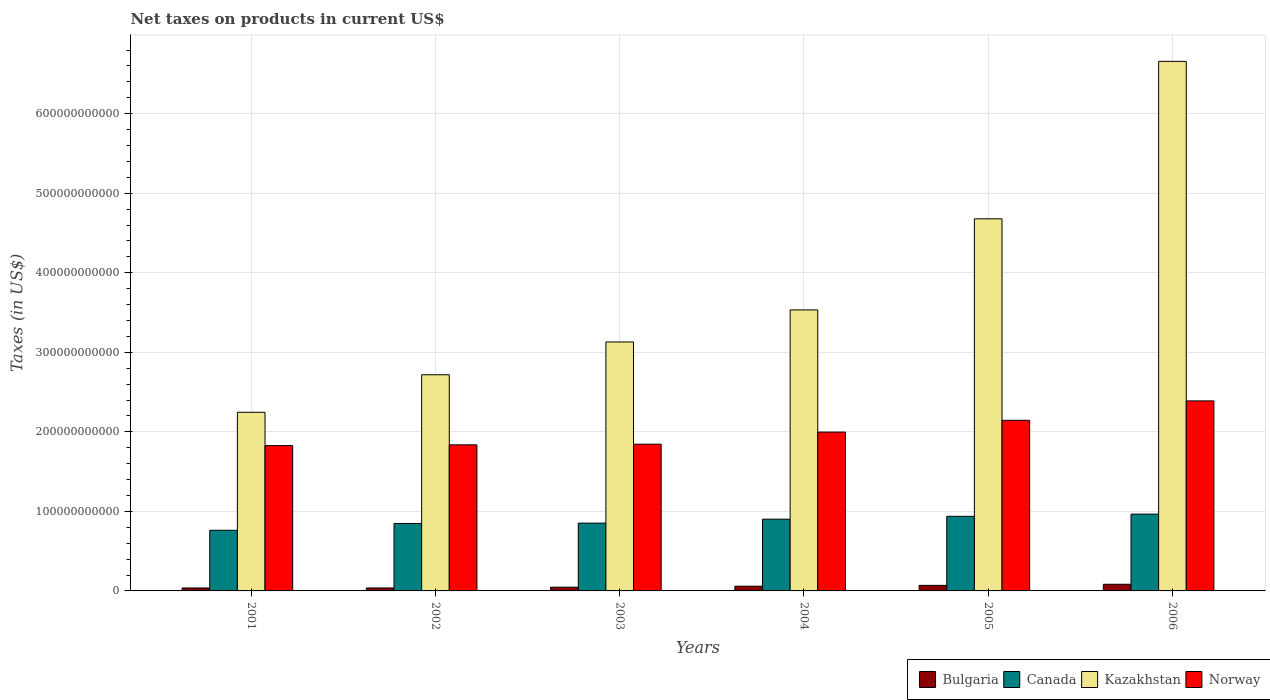How many different coloured bars are there?
Your answer should be compact. 4. How many groups of bars are there?
Give a very brief answer. 6. Are the number of bars per tick equal to the number of legend labels?
Your response must be concise. Yes. Are the number of bars on each tick of the X-axis equal?
Keep it short and to the point. Yes. How many bars are there on the 4th tick from the left?
Give a very brief answer. 4. How many bars are there on the 3rd tick from the right?
Offer a terse response. 4. What is the net taxes on products in Bulgaria in 2006?
Offer a terse response. 8.36e+09. Across all years, what is the maximum net taxes on products in Canada?
Provide a succinct answer. 9.66e+1. Across all years, what is the minimum net taxes on products in Kazakhstan?
Your answer should be compact. 2.25e+11. What is the total net taxes on products in Canada in the graph?
Offer a very short reply. 5.27e+11. What is the difference between the net taxes on products in Norway in 2001 and that in 2006?
Offer a very short reply. -5.62e+1. What is the difference between the net taxes on products in Kazakhstan in 2006 and the net taxes on products in Canada in 2004?
Your answer should be compact. 5.76e+11. What is the average net taxes on products in Canada per year?
Provide a succinct answer. 8.78e+1. In the year 2004, what is the difference between the net taxes on products in Norway and net taxes on products in Kazakhstan?
Make the answer very short. -1.54e+11. In how many years, is the net taxes on products in Kazakhstan greater than 180000000000 US$?
Provide a succinct answer. 6. What is the ratio of the net taxes on products in Norway in 2005 to that in 2006?
Keep it short and to the point. 0.9. Is the net taxes on products in Kazakhstan in 2001 less than that in 2002?
Your answer should be compact. Yes. What is the difference between the highest and the second highest net taxes on products in Norway?
Offer a terse response. 2.44e+1. What is the difference between the highest and the lowest net taxes on products in Canada?
Your response must be concise. 2.03e+1. Is the sum of the net taxes on products in Norway in 2001 and 2004 greater than the maximum net taxes on products in Bulgaria across all years?
Your answer should be very brief. Yes. What does the 4th bar from the left in 2006 represents?
Offer a very short reply. Norway. Is it the case that in every year, the sum of the net taxes on products in Norway and net taxes on products in Kazakhstan is greater than the net taxes on products in Canada?
Your answer should be very brief. Yes. What is the difference between two consecutive major ticks on the Y-axis?
Ensure brevity in your answer.  1.00e+11. Does the graph contain any zero values?
Ensure brevity in your answer.  No. Does the graph contain grids?
Keep it short and to the point. Yes. What is the title of the graph?
Keep it short and to the point. Net taxes on products in current US$. Does "Libya" appear as one of the legend labels in the graph?
Your answer should be compact. No. What is the label or title of the X-axis?
Give a very brief answer. Years. What is the label or title of the Y-axis?
Your answer should be compact. Taxes (in US$). What is the Taxes (in US$) of Bulgaria in 2001?
Offer a terse response. 3.70e+09. What is the Taxes (in US$) in Canada in 2001?
Offer a very short reply. 7.62e+1. What is the Taxes (in US$) in Kazakhstan in 2001?
Your answer should be very brief. 2.25e+11. What is the Taxes (in US$) in Norway in 2001?
Provide a succinct answer. 1.83e+11. What is the Taxes (in US$) of Bulgaria in 2002?
Make the answer very short. 3.73e+09. What is the Taxes (in US$) of Canada in 2002?
Offer a very short reply. 8.48e+1. What is the Taxes (in US$) in Kazakhstan in 2002?
Provide a short and direct response. 2.72e+11. What is the Taxes (in US$) in Norway in 2002?
Provide a succinct answer. 1.84e+11. What is the Taxes (in US$) in Bulgaria in 2003?
Offer a very short reply. 4.69e+09. What is the Taxes (in US$) of Canada in 2003?
Offer a terse response. 8.53e+1. What is the Taxes (in US$) in Kazakhstan in 2003?
Keep it short and to the point. 3.13e+11. What is the Taxes (in US$) in Norway in 2003?
Provide a short and direct response. 1.85e+11. What is the Taxes (in US$) in Bulgaria in 2004?
Your response must be concise. 5.94e+09. What is the Taxes (in US$) of Canada in 2004?
Offer a terse response. 9.02e+1. What is the Taxes (in US$) of Kazakhstan in 2004?
Keep it short and to the point. 3.53e+11. What is the Taxes (in US$) of Norway in 2004?
Give a very brief answer. 2.00e+11. What is the Taxes (in US$) of Bulgaria in 2005?
Provide a short and direct response. 6.99e+09. What is the Taxes (in US$) of Canada in 2005?
Ensure brevity in your answer.  9.38e+1. What is the Taxes (in US$) in Kazakhstan in 2005?
Ensure brevity in your answer.  4.68e+11. What is the Taxes (in US$) in Norway in 2005?
Provide a succinct answer. 2.15e+11. What is the Taxes (in US$) of Bulgaria in 2006?
Your answer should be compact. 8.36e+09. What is the Taxes (in US$) of Canada in 2006?
Your answer should be compact. 9.66e+1. What is the Taxes (in US$) in Kazakhstan in 2006?
Offer a very short reply. 6.66e+11. What is the Taxes (in US$) of Norway in 2006?
Your answer should be very brief. 2.39e+11. Across all years, what is the maximum Taxes (in US$) of Bulgaria?
Make the answer very short. 8.36e+09. Across all years, what is the maximum Taxes (in US$) in Canada?
Offer a very short reply. 9.66e+1. Across all years, what is the maximum Taxes (in US$) in Kazakhstan?
Your response must be concise. 6.66e+11. Across all years, what is the maximum Taxes (in US$) in Norway?
Your answer should be compact. 2.39e+11. Across all years, what is the minimum Taxes (in US$) in Bulgaria?
Offer a very short reply. 3.70e+09. Across all years, what is the minimum Taxes (in US$) of Canada?
Provide a short and direct response. 7.62e+1. Across all years, what is the minimum Taxes (in US$) of Kazakhstan?
Offer a terse response. 2.25e+11. Across all years, what is the minimum Taxes (in US$) of Norway?
Offer a very short reply. 1.83e+11. What is the total Taxes (in US$) in Bulgaria in the graph?
Ensure brevity in your answer.  3.34e+1. What is the total Taxes (in US$) of Canada in the graph?
Your response must be concise. 5.27e+11. What is the total Taxes (in US$) of Kazakhstan in the graph?
Provide a short and direct response. 2.30e+12. What is the total Taxes (in US$) in Norway in the graph?
Provide a short and direct response. 1.20e+12. What is the difference between the Taxes (in US$) in Bulgaria in 2001 and that in 2002?
Make the answer very short. -3.24e+07. What is the difference between the Taxes (in US$) of Canada in 2001 and that in 2002?
Provide a short and direct response. -8.55e+09. What is the difference between the Taxes (in US$) in Kazakhstan in 2001 and that in 2002?
Your answer should be compact. -4.72e+1. What is the difference between the Taxes (in US$) of Norway in 2001 and that in 2002?
Your answer should be compact. -9.57e+08. What is the difference between the Taxes (in US$) in Bulgaria in 2001 and that in 2003?
Offer a very short reply. -9.96e+08. What is the difference between the Taxes (in US$) in Canada in 2001 and that in 2003?
Your answer should be compact. -9.03e+09. What is the difference between the Taxes (in US$) in Kazakhstan in 2001 and that in 2003?
Your answer should be very brief. -8.84e+1. What is the difference between the Taxes (in US$) of Norway in 2001 and that in 2003?
Provide a succinct answer. -1.81e+09. What is the difference between the Taxes (in US$) of Bulgaria in 2001 and that in 2004?
Offer a terse response. -2.25e+09. What is the difference between the Taxes (in US$) of Canada in 2001 and that in 2004?
Give a very brief answer. -1.40e+1. What is the difference between the Taxes (in US$) of Kazakhstan in 2001 and that in 2004?
Provide a succinct answer. -1.29e+11. What is the difference between the Taxes (in US$) in Norway in 2001 and that in 2004?
Provide a succinct answer. -1.70e+1. What is the difference between the Taxes (in US$) of Bulgaria in 2001 and that in 2005?
Ensure brevity in your answer.  -3.29e+09. What is the difference between the Taxes (in US$) of Canada in 2001 and that in 2005?
Provide a succinct answer. -1.75e+1. What is the difference between the Taxes (in US$) in Kazakhstan in 2001 and that in 2005?
Your answer should be very brief. -2.43e+11. What is the difference between the Taxes (in US$) of Norway in 2001 and that in 2005?
Your answer should be compact. -3.18e+1. What is the difference between the Taxes (in US$) in Bulgaria in 2001 and that in 2006?
Provide a succinct answer. -4.66e+09. What is the difference between the Taxes (in US$) in Canada in 2001 and that in 2006?
Make the answer very short. -2.03e+1. What is the difference between the Taxes (in US$) of Kazakhstan in 2001 and that in 2006?
Your answer should be very brief. -4.41e+11. What is the difference between the Taxes (in US$) in Norway in 2001 and that in 2006?
Keep it short and to the point. -5.62e+1. What is the difference between the Taxes (in US$) in Bulgaria in 2002 and that in 2003?
Your response must be concise. -9.63e+08. What is the difference between the Taxes (in US$) of Canada in 2002 and that in 2003?
Your response must be concise. -4.84e+08. What is the difference between the Taxes (in US$) of Kazakhstan in 2002 and that in 2003?
Give a very brief answer. -4.12e+1. What is the difference between the Taxes (in US$) of Norway in 2002 and that in 2003?
Provide a short and direct response. -8.49e+08. What is the difference between the Taxes (in US$) in Bulgaria in 2002 and that in 2004?
Provide a short and direct response. -2.21e+09. What is the difference between the Taxes (in US$) in Canada in 2002 and that in 2004?
Give a very brief answer. -5.42e+09. What is the difference between the Taxes (in US$) of Kazakhstan in 2002 and that in 2004?
Offer a terse response. -8.15e+1. What is the difference between the Taxes (in US$) of Norway in 2002 and that in 2004?
Your response must be concise. -1.60e+1. What is the difference between the Taxes (in US$) in Bulgaria in 2002 and that in 2005?
Offer a terse response. -3.26e+09. What is the difference between the Taxes (in US$) of Canada in 2002 and that in 2005?
Give a very brief answer. -8.98e+09. What is the difference between the Taxes (in US$) in Kazakhstan in 2002 and that in 2005?
Ensure brevity in your answer.  -1.96e+11. What is the difference between the Taxes (in US$) in Norway in 2002 and that in 2005?
Offer a terse response. -3.08e+1. What is the difference between the Taxes (in US$) in Bulgaria in 2002 and that in 2006?
Offer a terse response. -4.63e+09. What is the difference between the Taxes (in US$) of Canada in 2002 and that in 2006?
Provide a short and direct response. -1.18e+1. What is the difference between the Taxes (in US$) in Kazakhstan in 2002 and that in 2006?
Offer a very short reply. -3.94e+11. What is the difference between the Taxes (in US$) in Norway in 2002 and that in 2006?
Offer a very short reply. -5.53e+1. What is the difference between the Taxes (in US$) in Bulgaria in 2003 and that in 2004?
Ensure brevity in your answer.  -1.25e+09. What is the difference between the Taxes (in US$) of Canada in 2003 and that in 2004?
Ensure brevity in your answer.  -4.94e+09. What is the difference between the Taxes (in US$) in Kazakhstan in 2003 and that in 2004?
Your answer should be compact. -4.03e+1. What is the difference between the Taxes (in US$) of Norway in 2003 and that in 2004?
Your response must be concise. -1.52e+1. What is the difference between the Taxes (in US$) in Bulgaria in 2003 and that in 2005?
Keep it short and to the point. -2.30e+09. What is the difference between the Taxes (in US$) in Canada in 2003 and that in 2005?
Provide a succinct answer. -8.50e+09. What is the difference between the Taxes (in US$) in Kazakhstan in 2003 and that in 2005?
Provide a short and direct response. -1.55e+11. What is the difference between the Taxes (in US$) of Norway in 2003 and that in 2005?
Provide a short and direct response. -3.00e+1. What is the difference between the Taxes (in US$) of Bulgaria in 2003 and that in 2006?
Offer a very short reply. -3.67e+09. What is the difference between the Taxes (in US$) of Canada in 2003 and that in 2006?
Make the answer very short. -1.13e+1. What is the difference between the Taxes (in US$) of Kazakhstan in 2003 and that in 2006?
Offer a terse response. -3.53e+11. What is the difference between the Taxes (in US$) of Norway in 2003 and that in 2006?
Provide a succinct answer. -5.44e+1. What is the difference between the Taxes (in US$) of Bulgaria in 2004 and that in 2005?
Provide a short and direct response. -1.05e+09. What is the difference between the Taxes (in US$) in Canada in 2004 and that in 2005?
Your response must be concise. -3.56e+09. What is the difference between the Taxes (in US$) of Kazakhstan in 2004 and that in 2005?
Your answer should be very brief. -1.15e+11. What is the difference between the Taxes (in US$) in Norway in 2004 and that in 2005?
Your answer should be compact. -1.48e+1. What is the difference between the Taxes (in US$) of Bulgaria in 2004 and that in 2006?
Provide a short and direct response. -2.42e+09. What is the difference between the Taxes (in US$) of Canada in 2004 and that in 2006?
Ensure brevity in your answer.  -6.34e+09. What is the difference between the Taxes (in US$) in Kazakhstan in 2004 and that in 2006?
Offer a terse response. -3.13e+11. What is the difference between the Taxes (in US$) of Norway in 2004 and that in 2006?
Provide a short and direct response. -3.92e+1. What is the difference between the Taxes (in US$) of Bulgaria in 2005 and that in 2006?
Offer a terse response. -1.37e+09. What is the difference between the Taxes (in US$) of Canada in 2005 and that in 2006?
Provide a short and direct response. -2.78e+09. What is the difference between the Taxes (in US$) in Kazakhstan in 2005 and that in 2006?
Provide a succinct answer. -1.98e+11. What is the difference between the Taxes (in US$) in Norway in 2005 and that in 2006?
Ensure brevity in your answer.  -2.44e+1. What is the difference between the Taxes (in US$) of Bulgaria in 2001 and the Taxes (in US$) of Canada in 2002?
Offer a terse response. -8.11e+1. What is the difference between the Taxes (in US$) of Bulgaria in 2001 and the Taxes (in US$) of Kazakhstan in 2002?
Provide a succinct answer. -2.68e+11. What is the difference between the Taxes (in US$) in Bulgaria in 2001 and the Taxes (in US$) in Norway in 2002?
Your response must be concise. -1.80e+11. What is the difference between the Taxes (in US$) in Canada in 2001 and the Taxes (in US$) in Kazakhstan in 2002?
Your answer should be compact. -1.96e+11. What is the difference between the Taxes (in US$) of Canada in 2001 and the Taxes (in US$) of Norway in 2002?
Offer a very short reply. -1.07e+11. What is the difference between the Taxes (in US$) of Kazakhstan in 2001 and the Taxes (in US$) of Norway in 2002?
Make the answer very short. 4.10e+1. What is the difference between the Taxes (in US$) in Bulgaria in 2001 and the Taxes (in US$) in Canada in 2003?
Keep it short and to the point. -8.16e+1. What is the difference between the Taxes (in US$) of Bulgaria in 2001 and the Taxes (in US$) of Kazakhstan in 2003?
Provide a short and direct response. -3.09e+11. What is the difference between the Taxes (in US$) of Bulgaria in 2001 and the Taxes (in US$) of Norway in 2003?
Your response must be concise. -1.81e+11. What is the difference between the Taxes (in US$) in Canada in 2001 and the Taxes (in US$) in Kazakhstan in 2003?
Your answer should be very brief. -2.37e+11. What is the difference between the Taxes (in US$) of Canada in 2001 and the Taxes (in US$) of Norway in 2003?
Your answer should be very brief. -1.08e+11. What is the difference between the Taxes (in US$) in Kazakhstan in 2001 and the Taxes (in US$) in Norway in 2003?
Make the answer very short. 4.01e+1. What is the difference between the Taxes (in US$) of Bulgaria in 2001 and the Taxes (in US$) of Canada in 2004?
Provide a succinct answer. -8.65e+1. What is the difference between the Taxes (in US$) in Bulgaria in 2001 and the Taxes (in US$) in Kazakhstan in 2004?
Make the answer very short. -3.50e+11. What is the difference between the Taxes (in US$) in Bulgaria in 2001 and the Taxes (in US$) in Norway in 2004?
Your response must be concise. -1.96e+11. What is the difference between the Taxes (in US$) in Canada in 2001 and the Taxes (in US$) in Kazakhstan in 2004?
Provide a succinct answer. -2.77e+11. What is the difference between the Taxes (in US$) of Canada in 2001 and the Taxes (in US$) of Norway in 2004?
Provide a succinct answer. -1.23e+11. What is the difference between the Taxes (in US$) in Kazakhstan in 2001 and the Taxes (in US$) in Norway in 2004?
Your answer should be very brief. 2.49e+1. What is the difference between the Taxes (in US$) in Bulgaria in 2001 and the Taxes (in US$) in Canada in 2005?
Give a very brief answer. -9.01e+1. What is the difference between the Taxes (in US$) in Bulgaria in 2001 and the Taxes (in US$) in Kazakhstan in 2005?
Your answer should be very brief. -4.64e+11. What is the difference between the Taxes (in US$) of Bulgaria in 2001 and the Taxes (in US$) of Norway in 2005?
Provide a short and direct response. -2.11e+11. What is the difference between the Taxes (in US$) in Canada in 2001 and the Taxes (in US$) in Kazakhstan in 2005?
Ensure brevity in your answer.  -3.92e+11. What is the difference between the Taxes (in US$) in Canada in 2001 and the Taxes (in US$) in Norway in 2005?
Keep it short and to the point. -1.38e+11. What is the difference between the Taxes (in US$) of Kazakhstan in 2001 and the Taxes (in US$) of Norway in 2005?
Give a very brief answer. 1.01e+1. What is the difference between the Taxes (in US$) of Bulgaria in 2001 and the Taxes (in US$) of Canada in 2006?
Offer a very short reply. -9.29e+1. What is the difference between the Taxes (in US$) in Bulgaria in 2001 and the Taxes (in US$) in Kazakhstan in 2006?
Your answer should be compact. -6.62e+11. What is the difference between the Taxes (in US$) in Bulgaria in 2001 and the Taxes (in US$) in Norway in 2006?
Provide a short and direct response. -2.35e+11. What is the difference between the Taxes (in US$) in Canada in 2001 and the Taxes (in US$) in Kazakhstan in 2006?
Provide a succinct answer. -5.90e+11. What is the difference between the Taxes (in US$) in Canada in 2001 and the Taxes (in US$) in Norway in 2006?
Provide a succinct answer. -1.63e+11. What is the difference between the Taxes (in US$) of Kazakhstan in 2001 and the Taxes (in US$) of Norway in 2006?
Make the answer very short. -1.43e+1. What is the difference between the Taxes (in US$) of Bulgaria in 2002 and the Taxes (in US$) of Canada in 2003?
Provide a short and direct response. -8.15e+1. What is the difference between the Taxes (in US$) in Bulgaria in 2002 and the Taxes (in US$) in Kazakhstan in 2003?
Ensure brevity in your answer.  -3.09e+11. What is the difference between the Taxes (in US$) of Bulgaria in 2002 and the Taxes (in US$) of Norway in 2003?
Your answer should be very brief. -1.81e+11. What is the difference between the Taxes (in US$) of Canada in 2002 and the Taxes (in US$) of Kazakhstan in 2003?
Your answer should be very brief. -2.28e+11. What is the difference between the Taxes (in US$) in Canada in 2002 and the Taxes (in US$) in Norway in 2003?
Offer a terse response. -9.97e+1. What is the difference between the Taxes (in US$) of Kazakhstan in 2002 and the Taxes (in US$) of Norway in 2003?
Offer a very short reply. 8.73e+1. What is the difference between the Taxes (in US$) of Bulgaria in 2002 and the Taxes (in US$) of Canada in 2004?
Provide a short and direct response. -8.65e+1. What is the difference between the Taxes (in US$) in Bulgaria in 2002 and the Taxes (in US$) in Kazakhstan in 2004?
Ensure brevity in your answer.  -3.50e+11. What is the difference between the Taxes (in US$) of Bulgaria in 2002 and the Taxes (in US$) of Norway in 2004?
Provide a short and direct response. -1.96e+11. What is the difference between the Taxes (in US$) in Canada in 2002 and the Taxes (in US$) in Kazakhstan in 2004?
Make the answer very short. -2.69e+11. What is the difference between the Taxes (in US$) in Canada in 2002 and the Taxes (in US$) in Norway in 2004?
Ensure brevity in your answer.  -1.15e+11. What is the difference between the Taxes (in US$) in Kazakhstan in 2002 and the Taxes (in US$) in Norway in 2004?
Keep it short and to the point. 7.21e+1. What is the difference between the Taxes (in US$) of Bulgaria in 2002 and the Taxes (in US$) of Canada in 2005?
Ensure brevity in your answer.  -9.00e+1. What is the difference between the Taxes (in US$) of Bulgaria in 2002 and the Taxes (in US$) of Kazakhstan in 2005?
Your answer should be very brief. -4.64e+11. What is the difference between the Taxes (in US$) in Bulgaria in 2002 and the Taxes (in US$) in Norway in 2005?
Your answer should be very brief. -2.11e+11. What is the difference between the Taxes (in US$) of Canada in 2002 and the Taxes (in US$) of Kazakhstan in 2005?
Your answer should be very brief. -3.83e+11. What is the difference between the Taxes (in US$) of Canada in 2002 and the Taxes (in US$) of Norway in 2005?
Give a very brief answer. -1.30e+11. What is the difference between the Taxes (in US$) in Kazakhstan in 2002 and the Taxes (in US$) in Norway in 2005?
Ensure brevity in your answer.  5.73e+1. What is the difference between the Taxes (in US$) in Bulgaria in 2002 and the Taxes (in US$) in Canada in 2006?
Ensure brevity in your answer.  -9.28e+1. What is the difference between the Taxes (in US$) of Bulgaria in 2002 and the Taxes (in US$) of Kazakhstan in 2006?
Provide a succinct answer. -6.62e+11. What is the difference between the Taxes (in US$) of Bulgaria in 2002 and the Taxes (in US$) of Norway in 2006?
Ensure brevity in your answer.  -2.35e+11. What is the difference between the Taxes (in US$) in Canada in 2002 and the Taxes (in US$) in Kazakhstan in 2006?
Provide a short and direct response. -5.81e+11. What is the difference between the Taxes (in US$) of Canada in 2002 and the Taxes (in US$) of Norway in 2006?
Provide a short and direct response. -1.54e+11. What is the difference between the Taxes (in US$) in Kazakhstan in 2002 and the Taxes (in US$) in Norway in 2006?
Your answer should be compact. 3.29e+1. What is the difference between the Taxes (in US$) in Bulgaria in 2003 and the Taxes (in US$) in Canada in 2004?
Offer a very short reply. -8.55e+1. What is the difference between the Taxes (in US$) in Bulgaria in 2003 and the Taxes (in US$) in Kazakhstan in 2004?
Your response must be concise. -3.49e+11. What is the difference between the Taxes (in US$) in Bulgaria in 2003 and the Taxes (in US$) in Norway in 2004?
Offer a terse response. -1.95e+11. What is the difference between the Taxes (in US$) of Canada in 2003 and the Taxes (in US$) of Kazakhstan in 2004?
Give a very brief answer. -2.68e+11. What is the difference between the Taxes (in US$) of Canada in 2003 and the Taxes (in US$) of Norway in 2004?
Your answer should be compact. -1.14e+11. What is the difference between the Taxes (in US$) of Kazakhstan in 2003 and the Taxes (in US$) of Norway in 2004?
Provide a succinct answer. 1.13e+11. What is the difference between the Taxes (in US$) in Bulgaria in 2003 and the Taxes (in US$) in Canada in 2005?
Your answer should be very brief. -8.91e+1. What is the difference between the Taxes (in US$) in Bulgaria in 2003 and the Taxes (in US$) in Kazakhstan in 2005?
Offer a very short reply. -4.63e+11. What is the difference between the Taxes (in US$) of Bulgaria in 2003 and the Taxes (in US$) of Norway in 2005?
Your answer should be compact. -2.10e+11. What is the difference between the Taxes (in US$) of Canada in 2003 and the Taxes (in US$) of Kazakhstan in 2005?
Offer a terse response. -3.83e+11. What is the difference between the Taxes (in US$) in Canada in 2003 and the Taxes (in US$) in Norway in 2005?
Your response must be concise. -1.29e+11. What is the difference between the Taxes (in US$) in Kazakhstan in 2003 and the Taxes (in US$) in Norway in 2005?
Your answer should be compact. 9.85e+1. What is the difference between the Taxes (in US$) of Bulgaria in 2003 and the Taxes (in US$) of Canada in 2006?
Offer a very short reply. -9.19e+1. What is the difference between the Taxes (in US$) of Bulgaria in 2003 and the Taxes (in US$) of Kazakhstan in 2006?
Provide a short and direct response. -6.61e+11. What is the difference between the Taxes (in US$) of Bulgaria in 2003 and the Taxes (in US$) of Norway in 2006?
Ensure brevity in your answer.  -2.34e+11. What is the difference between the Taxes (in US$) in Canada in 2003 and the Taxes (in US$) in Kazakhstan in 2006?
Your response must be concise. -5.81e+11. What is the difference between the Taxes (in US$) of Canada in 2003 and the Taxes (in US$) of Norway in 2006?
Keep it short and to the point. -1.54e+11. What is the difference between the Taxes (in US$) of Kazakhstan in 2003 and the Taxes (in US$) of Norway in 2006?
Your response must be concise. 7.41e+1. What is the difference between the Taxes (in US$) in Bulgaria in 2004 and the Taxes (in US$) in Canada in 2005?
Make the answer very short. -8.78e+1. What is the difference between the Taxes (in US$) of Bulgaria in 2004 and the Taxes (in US$) of Kazakhstan in 2005?
Offer a terse response. -4.62e+11. What is the difference between the Taxes (in US$) of Bulgaria in 2004 and the Taxes (in US$) of Norway in 2005?
Offer a very short reply. -2.09e+11. What is the difference between the Taxes (in US$) of Canada in 2004 and the Taxes (in US$) of Kazakhstan in 2005?
Keep it short and to the point. -3.78e+11. What is the difference between the Taxes (in US$) in Canada in 2004 and the Taxes (in US$) in Norway in 2005?
Offer a very short reply. -1.24e+11. What is the difference between the Taxes (in US$) of Kazakhstan in 2004 and the Taxes (in US$) of Norway in 2005?
Ensure brevity in your answer.  1.39e+11. What is the difference between the Taxes (in US$) in Bulgaria in 2004 and the Taxes (in US$) in Canada in 2006?
Your answer should be compact. -9.06e+1. What is the difference between the Taxes (in US$) in Bulgaria in 2004 and the Taxes (in US$) in Kazakhstan in 2006?
Provide a succinct answer. -6.60e+11. What is the difference between the Taxes (in US$) of Bulgaria in 2004 and the Taxes (in US$) of Norway in 2006?
Provide a short and direct response. -2.33e+11. What is the difference between the Taxes (in US$) in Canada in 2004 and the Taxes (in US$) in Kazakhstan in 2006?
Keep it short and to the point. -5.76e+11. What is the difference between the Taxes (in US$) in Canada in 2004 and the Taxes (in US$) in Norway in 2006?
Provide a succinct answer. -1.49e+11. What is the difference between the Taxes (in US$) of Kazakhstan in 2004 and the Taxes (in US$) of Norway in 2006?
Give a very brief answer. 1.14e+11. What is the difference between the Taxes (in US$) in Bulgaria in 2005 and the Taxes (in US$) in Canada in 2006?
Offer a terse response. -8.96e+1. What is the difference between the Taxes (in US$) in Bulgaria in 2005 and the Taxes (in US$) in Kazakhstan in 2006?
Your response must be concise. -6.59e+11. What is the difference between the Taxes (in US$) in Bulgaria in 2005 and the Taxes (in US$) in Norway in 2006?
Give a very brief answer. -2.32e+11. What is the difference between the Taxes (in US$) in Canada in 2005 and the Taxes (in US$) in Kazakhstan in 2006?
Ensure brevity in your answer.  -5.72e+11. What is the difference between the Taxes (in US$) in Canada in 2005 and the Taxes (in US$) in Norway in 2006?
Provide a succinct answer. -1.45e+11. What is the difference between the Taxes (in US$) of Kazakhstan in 2005 and the Taxes (in US$) of Norway in 2006?
Provide a succinct answer. 2.29e+11. What is the average Taxes (in US$) in Bulgaria per year?
Offer a very short reply. 5.57e+09. What is the average Taxes (in US$) of Canada per year?
Provide a short and direct response. 8.78e+1. What is the average Taxes (in US$) in Kazakhstan per year?
Ensure brevity in your answer.  3.83e+11. What is the average Taxes (in US$) of Norway per year?
Make the answer very short. 2.01e+11. In the year 2001, what is the difference between the Taxes (in US$) in Bulgaria and Taxes (in US$) in Canada?
Ensure brevity in your answer.  -7.25e+1. In the year 2001, what is the difference between the Taxes (in US$) in Bulgaria and Taxes (in US$) in Kazakhstan?
Make the answer very short. -2.21e+11. In the year 2001, what is the difference between the Taxes (in US$) of Bulgaria and Taxes (in US$) of Norway?
Your answer should be compact. -1.79e+11. In the year 2001, what is the difference between the Taxes (in US$) of Canada and Taxes (in US$) of Kazakhstan?
Offer a very short reply. -1.48e+11. In the year 2001, what is the difference between the Taxes (in US$) of Canada and Taxes (in US$) of Norway?
Give a very brief answer. -1.06e+11. In the year 2001, what is the difference between the Taxes (in US$) of Kazakhstan and Taxes (in US$) of Norway?
Your response must be concise. 4.19e+1. In the year 2002, what is the difference between the Taxes (in US$) of Bulgaria and Taxes (in US$) of Canada?
Provide a short and direct response. -8.11e+1. In the year 2002, what is the difference between the Taxes (in US$) in Bulgaria and Taxes (in US$) in Kazakhstan?
Keep it short and to the point. -2.68e+11. In the year 2002, what is the difference between the Taxes (in US$) of Bulgaria and Taxes (in US$) of Norway?
Ensure brevity in your answer.  -1.80e+11. In the year 2002, what is the difference between the Taxes (in US$) of Canada and Taxes (in US$) of Kazakhstan?
Your answer should be very brief. -1.87e+11. In the year 2002, what is the difference between the Taxes (in US$) in Canada and Taxes (in US$) in Norway?
Offer a very short reply. -9.89e+1. In the year 2002, what is the difference between the Taxes (in US$) in Kazakhstan and Taxes (in US$) in Norway?
Offer a very short reply. 8.81e+1. In the year 2003, what is the difference between the Taxes (in US$) of Bulgaria and Taxes (in US$) of Canada?
Your answer should be compact. -8.06e+1. In the year 2003, what is the difference between the Taxes (in US$) in Bulgaria and Taxes (in US$) in Kazakhstan?
Provide a succinct answer. -3.08e+11. In the year 2003, what is the difference between the Taxes (in US$) of Bulgaria and Taxes (in US$) of Norway?
Give a very brief answer. -1.80e+11. In the year 2003, what is the difference between the Taxes (in US$) of Canada and Taxes (in US$) of Kazakhstan?
Your answer should be very brief. -2.28e+11. In the year 2003, what is the difference between the Taxes (in US$) in Canada and Taxes (in US$) in Norway?
Ensure brevity in your answer.  -9.92e+1. In the year 2003, what is the difference between the Taxes (in US$) of Kazakhstan and Taxes (in US$) of Norway?
Ensure brevity in your answer.  1.29e+11. In the year 2004, what is the difference between the Taxes (in US$) of Bulgaria and Taxes (in US$) of Canada?
Give a very brief answer. -8.43e+1. In the year 2004, what is the difference between the Taxes (in US$) in Bulgaria and Taxes (in US$) in Kazakhstan?
Your response must be concise. -3.47e+11. In the year 2004, what is the difference between the Taxes (in US$) of Bulgaria and Taxes (in US$) of Norway?
Your answer should be compact. -1.94e+11. In the year 2004, what is the difference between the Taxes (in US$) of Canada and Taxes (in US$) of Kazakhstan?
Your answer should be compact. -2.63e+11. In the year 2004, what is the difference between the Taxes (in US$) of Canada and Taxes (in US$) of Norway?
Provide a short and direct response. -1.09e+11. In the year 2004, what is the difference between the Taxes (in US$) of Kazakhstan and Taxes (in US$) of Norway?
Keep it short and to the point. 1.54e+11. In the year 2005, what is the difference between the Taxes (in US$) of Bulgaria and Taxes (in US$) of Canada?
Provide a short and direct response. -8.68e+1. In the year 2005, what is the difference between the Taxes (in US$) of Bulgaria and Taxes (in US$) of Kazakhstan?
Offer a very short reply. -4.61e+11. In the year 2005, what is the difference between the Taxes (in US$) of Bulgaria and Taxes (in US$) of Norway?
Keep it short and to the point. -2.08e+11. In the year 2005, what is the difference between the Taxes (in US$) in Canada and Taxes (in US$) in Kazakhstan?
Your response must be concise. -3.74e+11. In the year 2005, what is the difference between the Taxes (in US$) in Canada and Taxes (in US$) in Norway?
Make the answer very short. -1.21e+11. In the year 2005, what is the difference between the Taxes (in US$) of Kazakhstan and Taxes (in US$) of Norway?
Keep it short and to the point. 2.53e+11. In the year 2006, what is the difference between the Taxes (in US$) of Bulgaria and Taxes (in US$) of Canada?
Provide a succinct answer. -8.82e+1. In the year 2006, what is the difference between the Taxes (in US$) in Bulgaria and Taxes (in US$) in Kazakhstan?
Offer a very short reply. -6.57e+11. In the year 2006, what is the difference between the Taxes (in US$) of Bulgaria and Taxes (in US$) of Norway?
Provide a short and direct response. -2.31e+11. In the year 2006, what is the difference between the Taxes (in US$) in Canada and Taxes (in US$) in Kazakhstan?
Your response must be concise. -5.69e+11. In the year 2006, what is the difference between the Taxes (in US$) in Canada and Taxes (in US$) in Norway?
Ensure brevity in your answer.  -1.42e+11. In the year 2006, what is the difference between the Taxes (in US$) in Kazakhstan and Taxes (in US$) in Norway?
Keep it short and to the point. 4.27e+11. What is the ratio of the Taxes (in US$) in Canada in 2001 to that in 2002?
Make the answer very short. 0.9. What is the ratio of the Taxes (in US$) in Kazakhstan in 2001 to that in 2002?
Your answer should be very brief. 0.83. What is the ratio of the Taxes (in US$) of Norway in 2001 to that in 2002?
Your answer should be very brief. 0.99. What is the ratio of the Taxes (in US$) in Bulgaria in 2001 to that in 2003?
Provide a succinct answer. 0.79. What is the ratio of the Taxes (in US$) in Canada in 2001 to that in 2003?
Provide a succinct answer. 0.89. What is the ratio of the Taxes (in US$) of Kazakhstan in 2001 to that in 2003?
Your answer should be very brief. 0.72. What is the ratio of the Taxes (in US$) of Norway in 2001 to that in 2003?
Ensure brevity in your answer.  0.99. What is the ratio of the Taxes (in US$) in Bulgaria in 2001 to that in 2004?
Your answer should be compact. 0.62. What is the ratio of the Taxes (in US$) of Canada in 2001 to that in 2004?
Your answer should be very brief. 0.85. What is the ratio of the Taxes (in US$) of Kazakhstan in 2001 to that in 2004?
Ensure brevity in your answer.  0.64. What is the ratio of the Taxes (in US$) in Norway in 2001 to that in 2004?
Make the answer very short. 0.91. What is the ratio of the Taxes (in US$) in Bulgaria in 2001 to that in 2005?
Your answer should be very brief. 0.53. What is the ratio of the Taxes (in US$) in Canada in 2001 to that in 2005?
Make the answer very short. 0.81. What is the ratio of the Taxes (in US$) in Kazakhstan in 2001 to that in 2005?
Give a very brief answer. 0.48. What is the ratio of the Taxes (in US$) of Norway in 2001 to that in 2005?
Your response must be concise. 0.85. What is the ratio of the Taxes (in US$) in Bulgaria in 2001 to that in 2006?
Your response must be concise. 0.44. What is the ratio of the Taxes (in US$) in Canada in 2001 to that in 2006?
Provide a short and direct response. 0.79. What is the ratio of the Taxes (in US$) in Kazakhstan in 2001 to that in 2006?
Keep it short and to the point. 0.34. What is the ratio of the Taxes (in US$) of Norway in 2001 to that in 2006?
Make the answer very short. 0.76. What is the ratio of the Taxes (in US$) of Bulgaria in 2002 to that in 2003?
Your answer should be compact. 0.79. What is the ratio of the Taxes (in US$) of Kazakhstan in 2002 to that in 2003?
Ensure brevity in your answer.  0.87. What is the ratio of the Taxes (in US$) of Norway in 2002 to that in 2003?
Provide a succinct answer. 1. What is the ratio of the Taxes (in US$) of Bulgaria in 2002 to that in 2004?
Ensure brevity in your answer.  0.63. What is the ratio of the Taxes (in US$) of Canada in 2002 to that in 2004?
Your response must be concise. 0.94. What is the ratio of the Taxes (in US$) of Kazakhstan in 2002 to that in 2004?
Your response must be concise. 0.77. What is the ratio of the Taxes (in US$) of Norway in 2002 to that in 2004?
Your answer should be compact. 0.92. What is the ratio of the Taxes (in US$) in Bulgaria in 2002 to that in 2005?
Give a very brief answer. 0.53. What is the ratio of the Taxes (in US$) in Canada in 2002 to that in 2005?
Ensure brevity in your answer.  0.9. What is the ratio of the Taxes (in US$) of Kazakhstan in 2002 to that in 2005?
Offer a very short reply. 0.58. What is the ratio of the Taxes (in US$) in Norway in 2002 to that in 2005?
Offer a terse response. 0.86. What is the ratio of the Taxes (in US$) of Bulgaria in 2002 to that in 2006?
Give a very brief answer. 0.45. What is the ratio of the Taxes (in US$) in Canada in 2002 to that in 2006?
Offer a terse response. 0.88. What is the ratio of the Taxes (in US$) in Kazakhstan in 2002 to that in 2006?
Ensure brevity in your answer.  0.41. What is the ratio of the Taxes (in US$) of Norway in 2002 to that in 2006?
Ensure brevity in your answer.  0.77. What is the ratio of the Taxes (in US$) in Bulgaria in 2003 to that in 2004?
Provide a short and direct response. 0.79. What is the ratio of the Taxes (in US$) of Canada in 2003 to that in 2004?
Your answer should be very brief. 0.95. What is the ratio of the Taxes (in US$) of Kazakhstan in 2003 to that in 2004?
Give a very brief answer. 0.89. What is the ratio of the Taxes (in US$) in Norway in 2003 to that in 2004?
Your answer should be very brief. 0.92. What is the ratio of the Taxes (in US$) of Bulgaria in 2003 to that in 2005?
Give a very brief answer. 0.67. What is the ratio of the Taxes (in US$) in Canada in 2003 to that in 2005?
Provide a short and direct response. 0.91. What is the ratio of the Taxes (in US$) in Kazakhstan in 2003 to that in 2005?
Ensure brevity in your answer.  0.67. What is the ratio of the Taxes (in US$) in Norway in 2003 to that in 2005?
Keep it short and to the point. 0.86. What is the ratio of the Taxes (in US$) of Bulgaria in 2003 to that in 2006?
Keep it short and to the point. 0.56. What is the ratio of the Taxes (in US$) of Canada in 2003 to that in 2006?
Give a very brief answer. 0.88. What is the ratio of the Taxes (in US$) in Kazakhstan in 2003 to that in 2006?
Keep it short and to the point. 0.47. What is the ratio of the Taxes (in US$) of Norway in 2003 to that in 2006?
Your response must be concise. 0.77. What is the ratio of the Taxes (in US$) of Bulgaria in 2004 to that in 2005?
Provide a short and direct response. 0.85. What is the ratio of the Taxes (in US$) in Kazakhstan in 2004 to that in 2005?
Keep it short and to the point. 0.76. What is the ratio of the Taxes (in US$) of Bulgaria in 2004 to that in 2006?
Give a very brief answer. 0.71. What is the ratio of the Taxes (in US$) of Canada in 2004 to that in 2006?
Your response must be concise. 0.93. What is the ratio of the Taxes (in US$) in Kazakhstan in 2004 to that in 2006?
Your answer should be very brief. 0.53. What is the ratio of the Taxes (in US$) of Norway in 2004 to that in 2006?
Provide a short and direct response. 0.84. What is the ratio of the Taxes (in US$) in Bulgaria in 2005 to that in 2006?
Make the answer very short. 0.84. What is the ratio of the Taxes (in US$) of Canada in 2005 to that in 2006?
Offer a terse response. 0.97. What is the ratio of the Taxes (in US$) of Kazakhstan in 2005 to that in 2006?
Give a very brief answer. 0.7. What is the ratio of the Taxes (in US$) in Norway in 2005 to that in 2006?
Keep it short and to the point. 0.9. What is the difference between the highest and the second highest Taxes (in US$) of Bulgaria?
Your answer should be very brief. 1.37e+09. What is the difference between the highest and the second highest Taxes (in US$) in Canada?
Give a very brief answer. 2.78e+09. What is the difference between the highest and the second highest Taxes (in US$) in Kazakhstan?
Offer a very short reply. 1.98e+11. What is the difference between the highest and the second highest Taxes (in US$) of Norway?
Offer a terse response. 2.44e+1. What is the difference between the highest and the lowest Taxes (in US$) in Bulgaria?
Keep it short and to the point. 4.66e+09. What is the difference between the highest and the lowest Taxes (in US$) of Canada?
Your answer should be compact. 2.03e+1. What is the difference between the highest and the lowest Taxes (in US$) in Kazakhstan?
Provide a short and direct response. 4.41e+11. What is the difference between the highest and the lowest Taxes (in US$) of Norway?
Provide a short and direct response. 5.62e+1. 